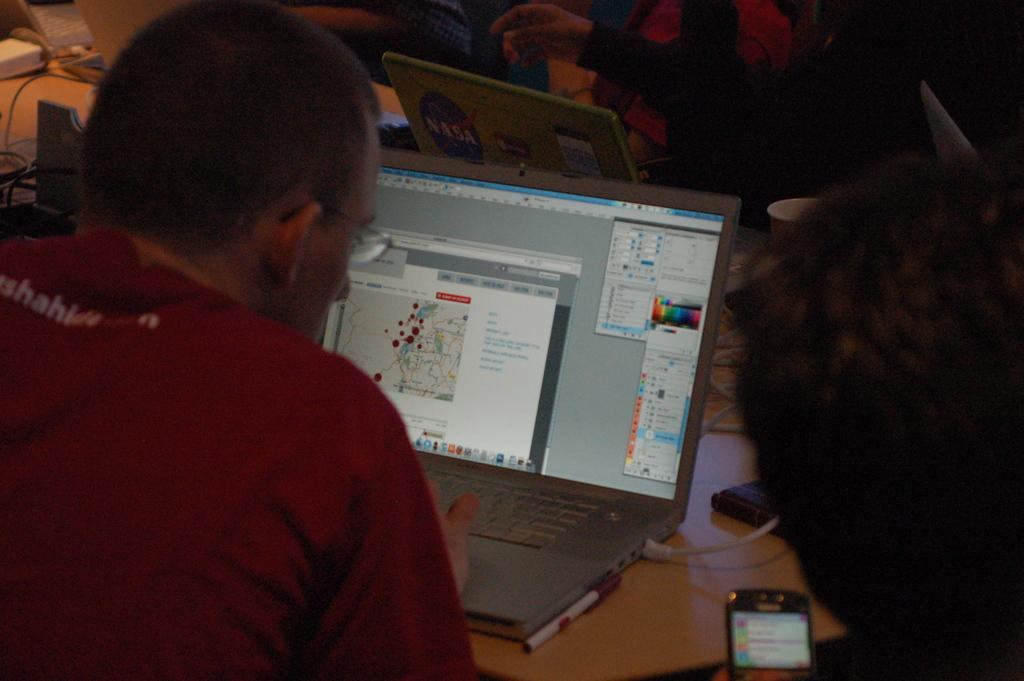What are the people in the image doing around the table? The people in the image are using laptops. Is there anyone using a different device in the image? Yes, there is a person using a mobile phone. What can be found on the table in the image? There are objects on the table. What type of notebook is the lawyer using in the image? There is no lawyer or notebook present in the image. What is the person using the hook for in the image? There is no hook present in the image. 